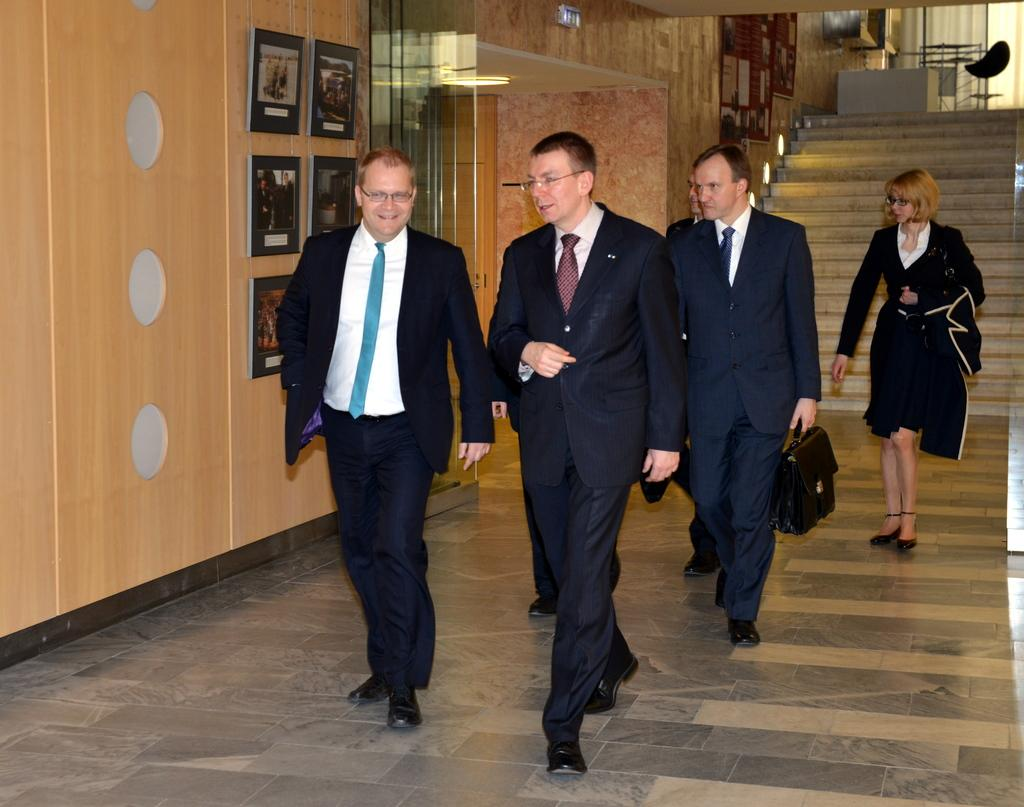How many people are in the image? There is a group of people in the image. What are the people in the image doing? The people are walking on the floor. What architectural feature can be seen in the image? There are steps in the image. What is hanging on the wall in the image? There are frames on the wall. What furniture can be seen in the background of the image? There is a chair in the background of the image. What type of window treatment is present in the image? There are windows with curtains in the background of the image. What type of soap is being used by the people in the image? There is no soap present in the image; the people are walking on the floor. What is the surprise element in the image? There is no surprise element in the image; it simply shows a group of people walking on the floor. 